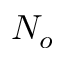<formula> <loc_0><loc_0><loc_500><loc_500>N _ { o }</formula> 